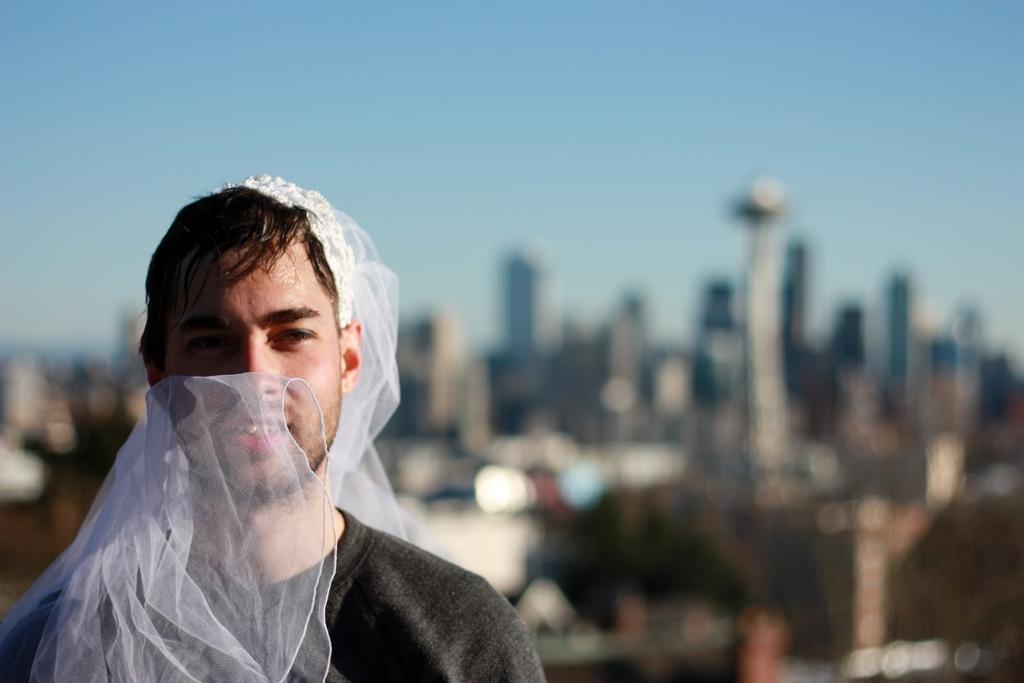What is the man in the image doing? The man is standing in the image. What expression does the man have on his face? The man is smiling. What can be seen in the background of the image? There are buildings in the background of the image. What part of the natural environment is visible in the image? The sky is visible in the image. What type of thrill can be seen in the man's eyes in the image? There is no indication of a thrill or any specific emotion in the man's eyes in the image. 